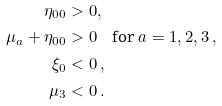<formula> <loc_0><loc_0><loc_500><loc_500>\eta _ { 0 0 } & > 0 , \\ \mu _ { a } + \eta _ { 0 0 } & > 0 \quad \text {for } a = 1 , 2 , 3 \, , \\ \xi _ { 0 } & < 0 \, , \\ \mu _ { 3 } & < 0 \, .</formula> 